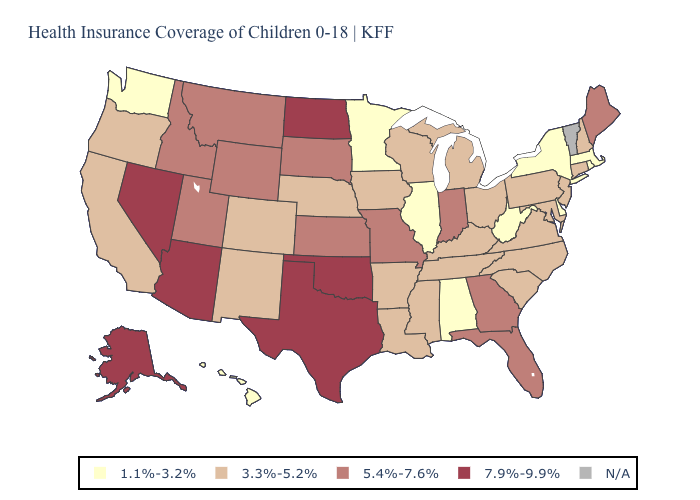Among the states that border New Jersey , does Pennsylvania have the lowest value?
Keep it brief. No. What is the value of South Carolina?
Be succinct. 3.3%-5.2%. Which states hav the highest value in the Northeast?
Keep it brief. Maine. Among the states that border Georgia , does Florida have the lowest value?
Write a very short answer. No. What is the lowest value in the West?
Be succinct. 1.1%-3.2%. Which states have the highest value in the USA?
Answer briefly. Alaska, Arizona, Nevada, North Dakota, Oklahoma, Texas. What is the value of Arkansas?
Quick response, please. 3.3%-5.2%. Name the states that have a value in the range 3.3%-5.2%?
Concise answer only. Arkansas, California, Colorado, Connecticut, Iowa, Kentucky, Louisiana, Maryland, Michigan, Mississippi, Nebraska, New Hampshire, New Jersey, New Mexico, North Carolina, Ohio, Oregon, Pennsylvania, South Carolina, Tennessee, Virginia, Wisconsin. Name the states that have a value in the range 7.9%-9.9%?
Give a very brief answer. Alaska, Arizona, Nevada, North Dakota, Oklahoma, Texas. How many symbols are there in the legend?
Write a very short answer. 5. What is the value of Oregon?
Be succinct. 3.3%-5.2%. Name the states that have a value in the range 1.1%-3.2%?
Write a very short answer. Alabama, Delaware, Hawaii, Illinois, Massachusetts, Minnesota, New York, Rhode Island, Washington, West Virginia. Is the legend a continuous bar?
Give a very brief answer. No. Name the states that have a value in the range N/A?
Concise answer only. Vermont. Does Hawaii have the lowest value in the USA?
Short answer required. Yes. 